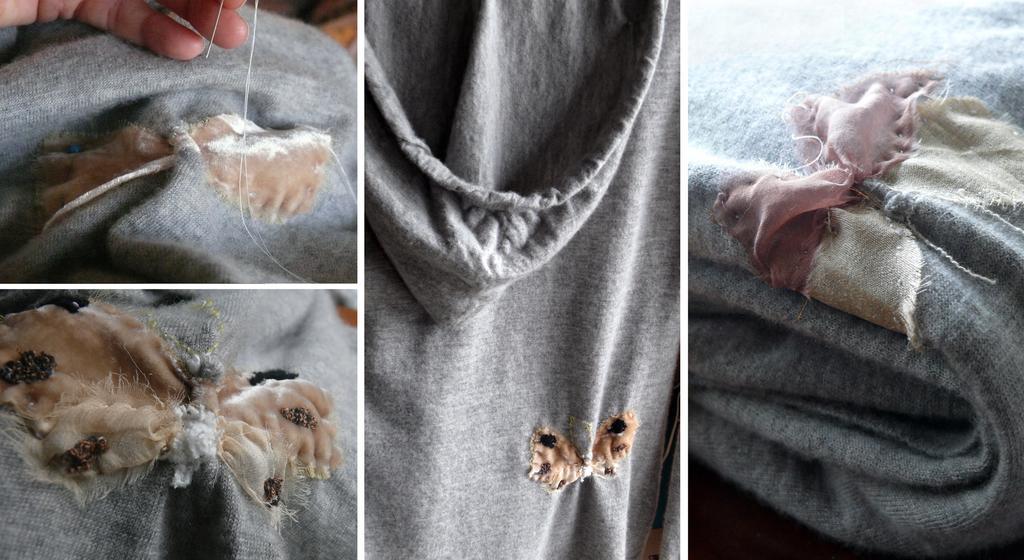Please provide a concise description of this image. Here we can see collage of four pictures, in these pictures we can see clothes, there is a hand of a person at the left top of the picture. 